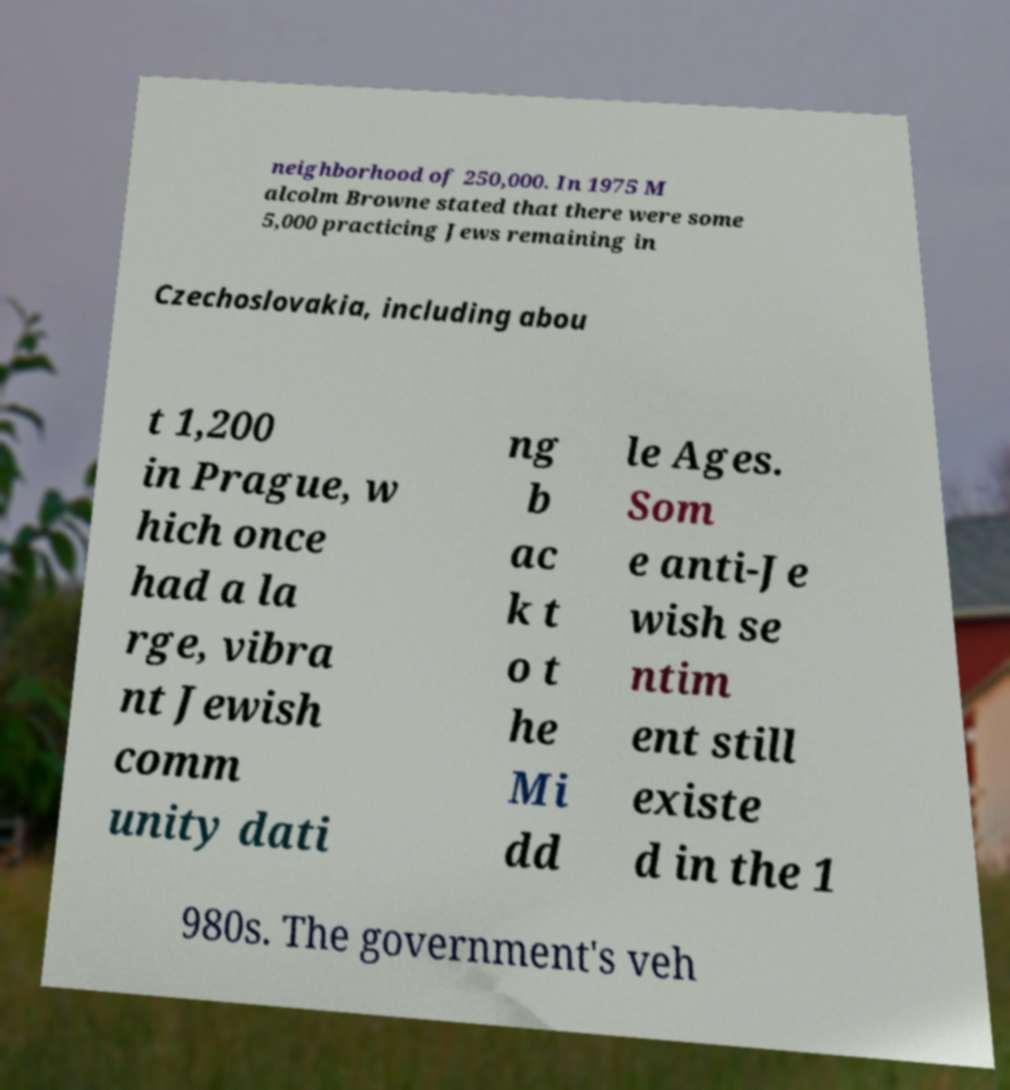Can you read and provide the text displayed in the image?This photo seems to have some interesting text. Can you extract and type it out for me? neighborhood of 250,000. In 1975 M alcolm Browne stated that there were some 5,000 practicing Jews remaining in Czechoslovakia, including abou t 1,200 in Prague, w hich once had a la rge, vibra nt Jewish comm unity dati ng b ac k t o t he Mi dd le Ages. Som e anti-Je wish se ntim ent still existe d in the 1 980s. The government's veh 